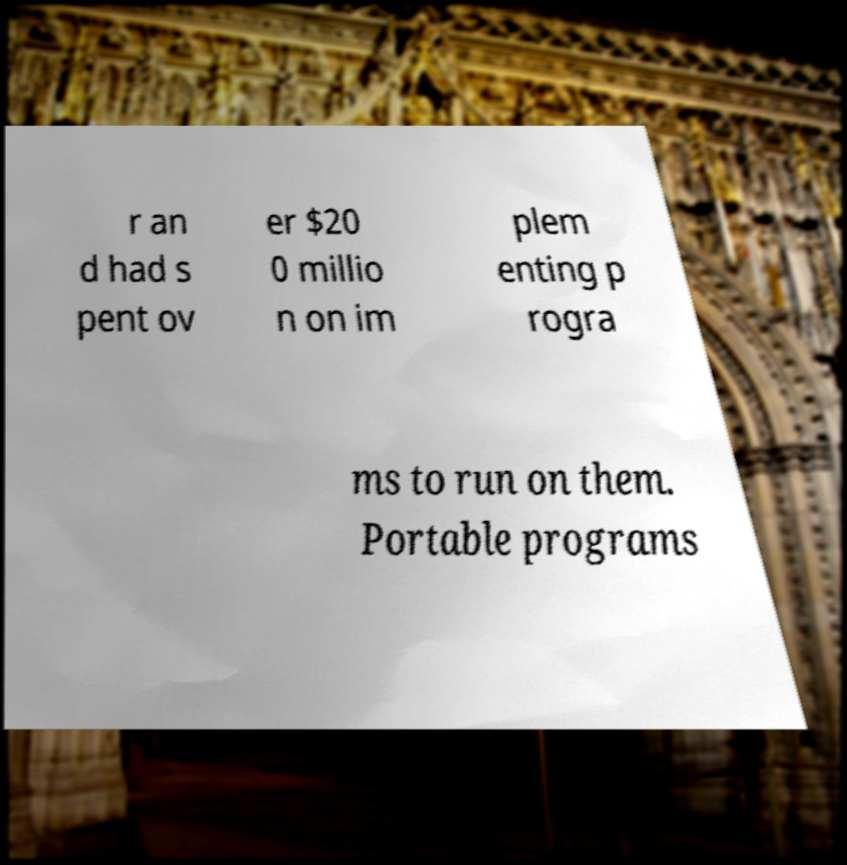Can you accurately transcribe the text from the provided image for me? r an d had s pent ov er $20 0 millio n on im plem enting p rogra ms to run on them. Portable programs 